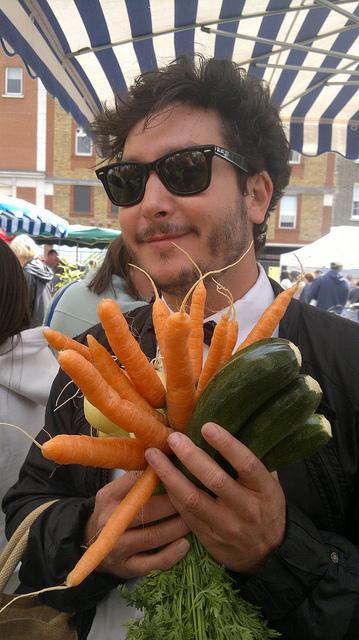What kind of green vegetable is held underneath of the carrots like a card?

Choices:
A) hops
B) cucumber
C) broccoli
D) spinach cucumber 